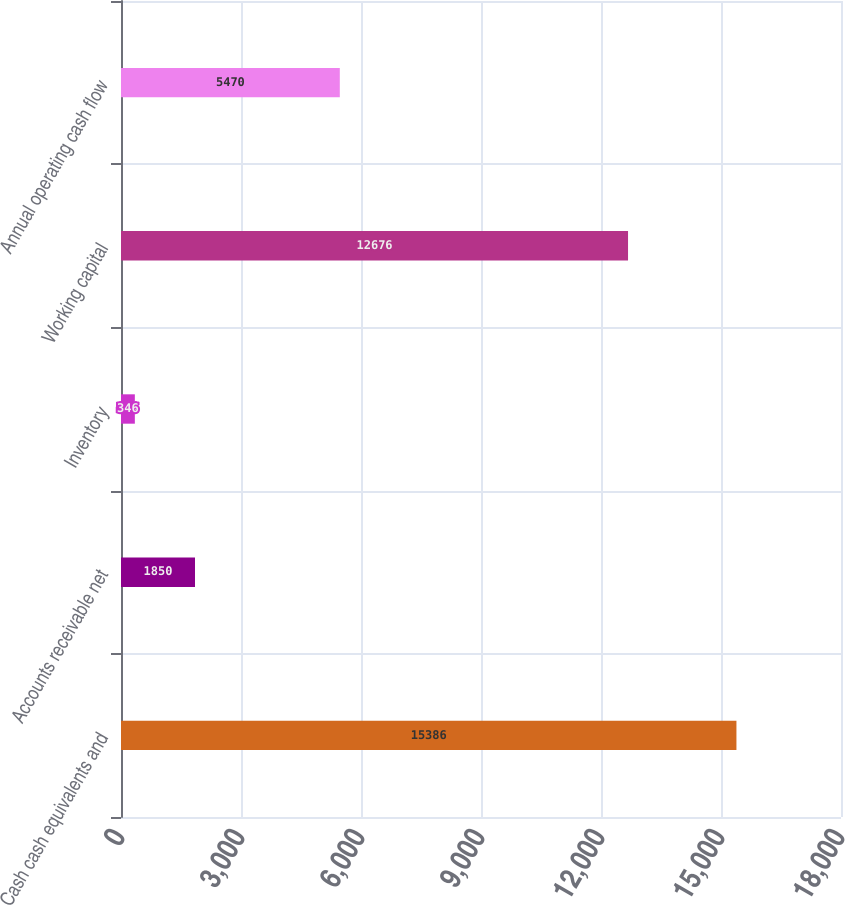Convert chart to OTSL. <chart><loc_0><loc_0><loc_500><loc_500><bar_chart><fcel>Cash cash equivalents and<fcel>Accounts receivable net<fcel>Inventory<fcel>Working capital<fcel>Annual operating cash flow<nl><fcel>15386<fcel>1850<fcel>346<fcel>12676<fcel>5470<nl></chart> 